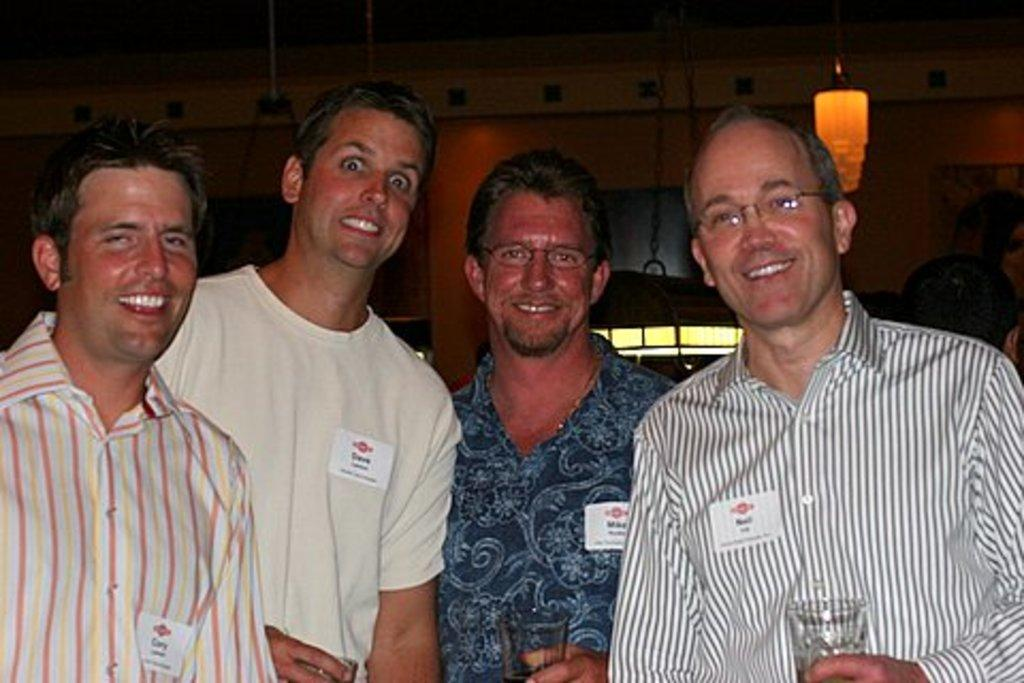What are the persons in the image doing? The persons in the image are standing and holding glasses. What can be seen in the background of the image? There is a wall, hangers, and a light in the background of the image. What type of brass instrument is being played by the persons in the image? There is no brass instrument present in the image; the persons are holding glasses. 